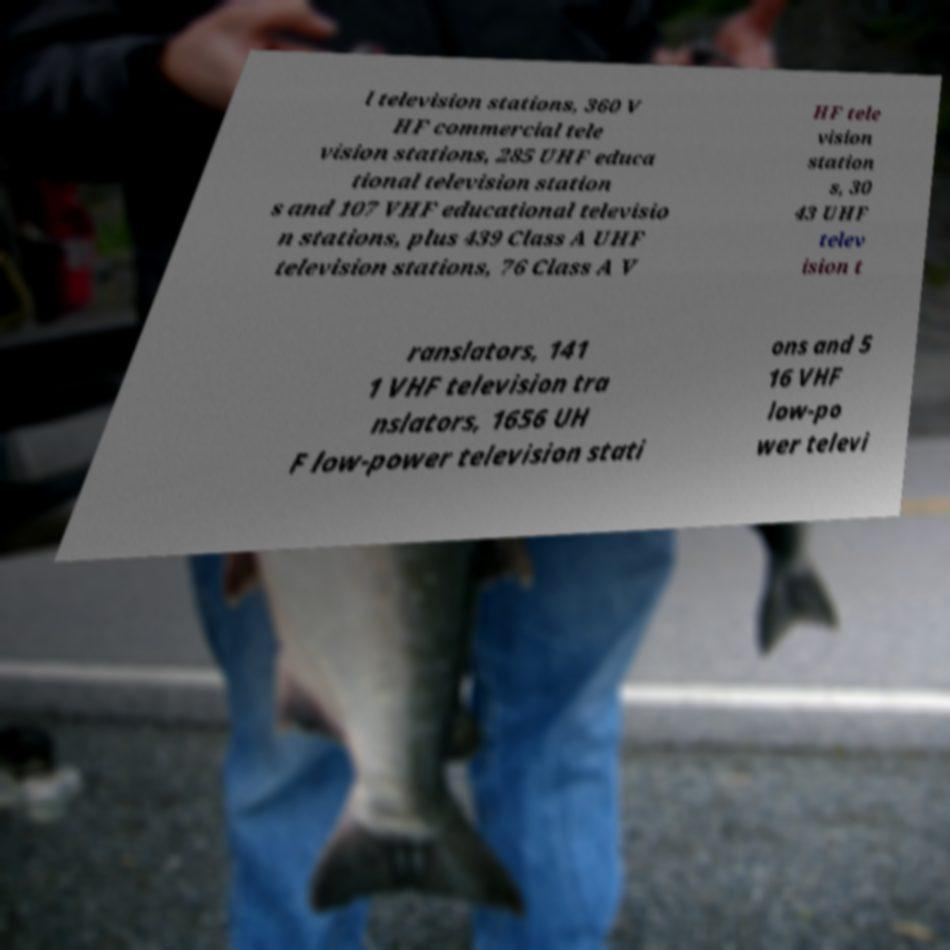Could you extract and type out the text from this image? l television stations, 360 V HF commercial tele vision stations, 285 UHF educa tional television station s and 107 VHF educational televisio n stations, plus 439 Class A UHF television stations, 76 Class A V HF tele vision station s, 30 43 UHF telev ision t ranslators, 141 1 VHF television tra nslators, 1656 UH F low-power television stati ons and 5 16 VHF low-po wer televi 